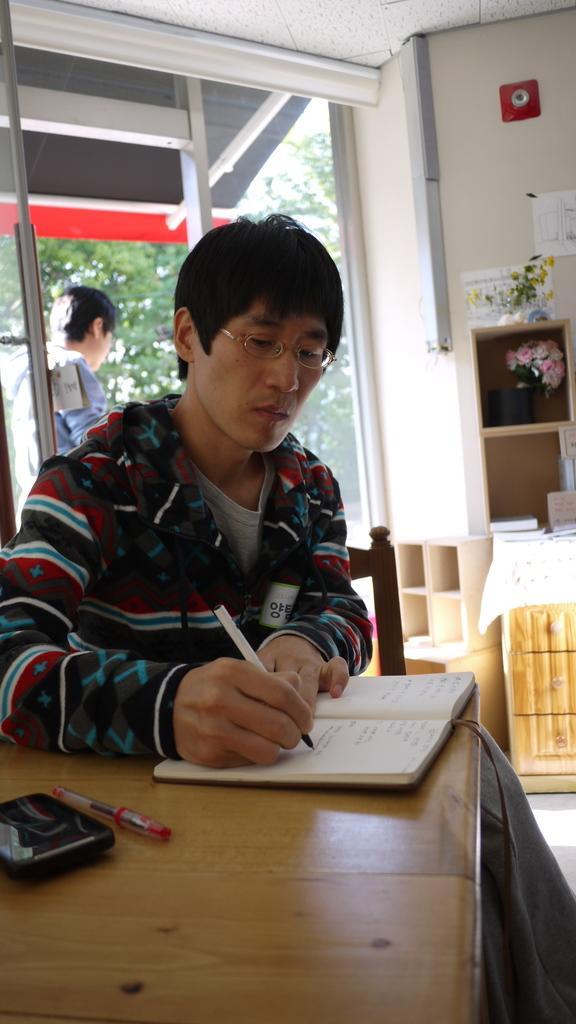Could you give a brief overview of what you see in this image? In the image we can see there are two men. This man is sitting and writing something in book. This is a chair, table, red pen and a device. 